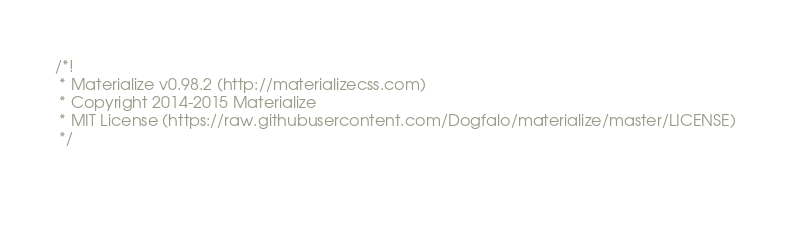<code> <loc_0><loc_0><loc_500><loc_500><_CSS_>/*!
 * Materialize v0.98.2 (http://materializecss.com)
 * Copyright 2014-2015 Materialize
 * MIT License (https://raw.githubusercontent.com/Dogfalo/materialize/master/LICENSE)
 */

 </code> 